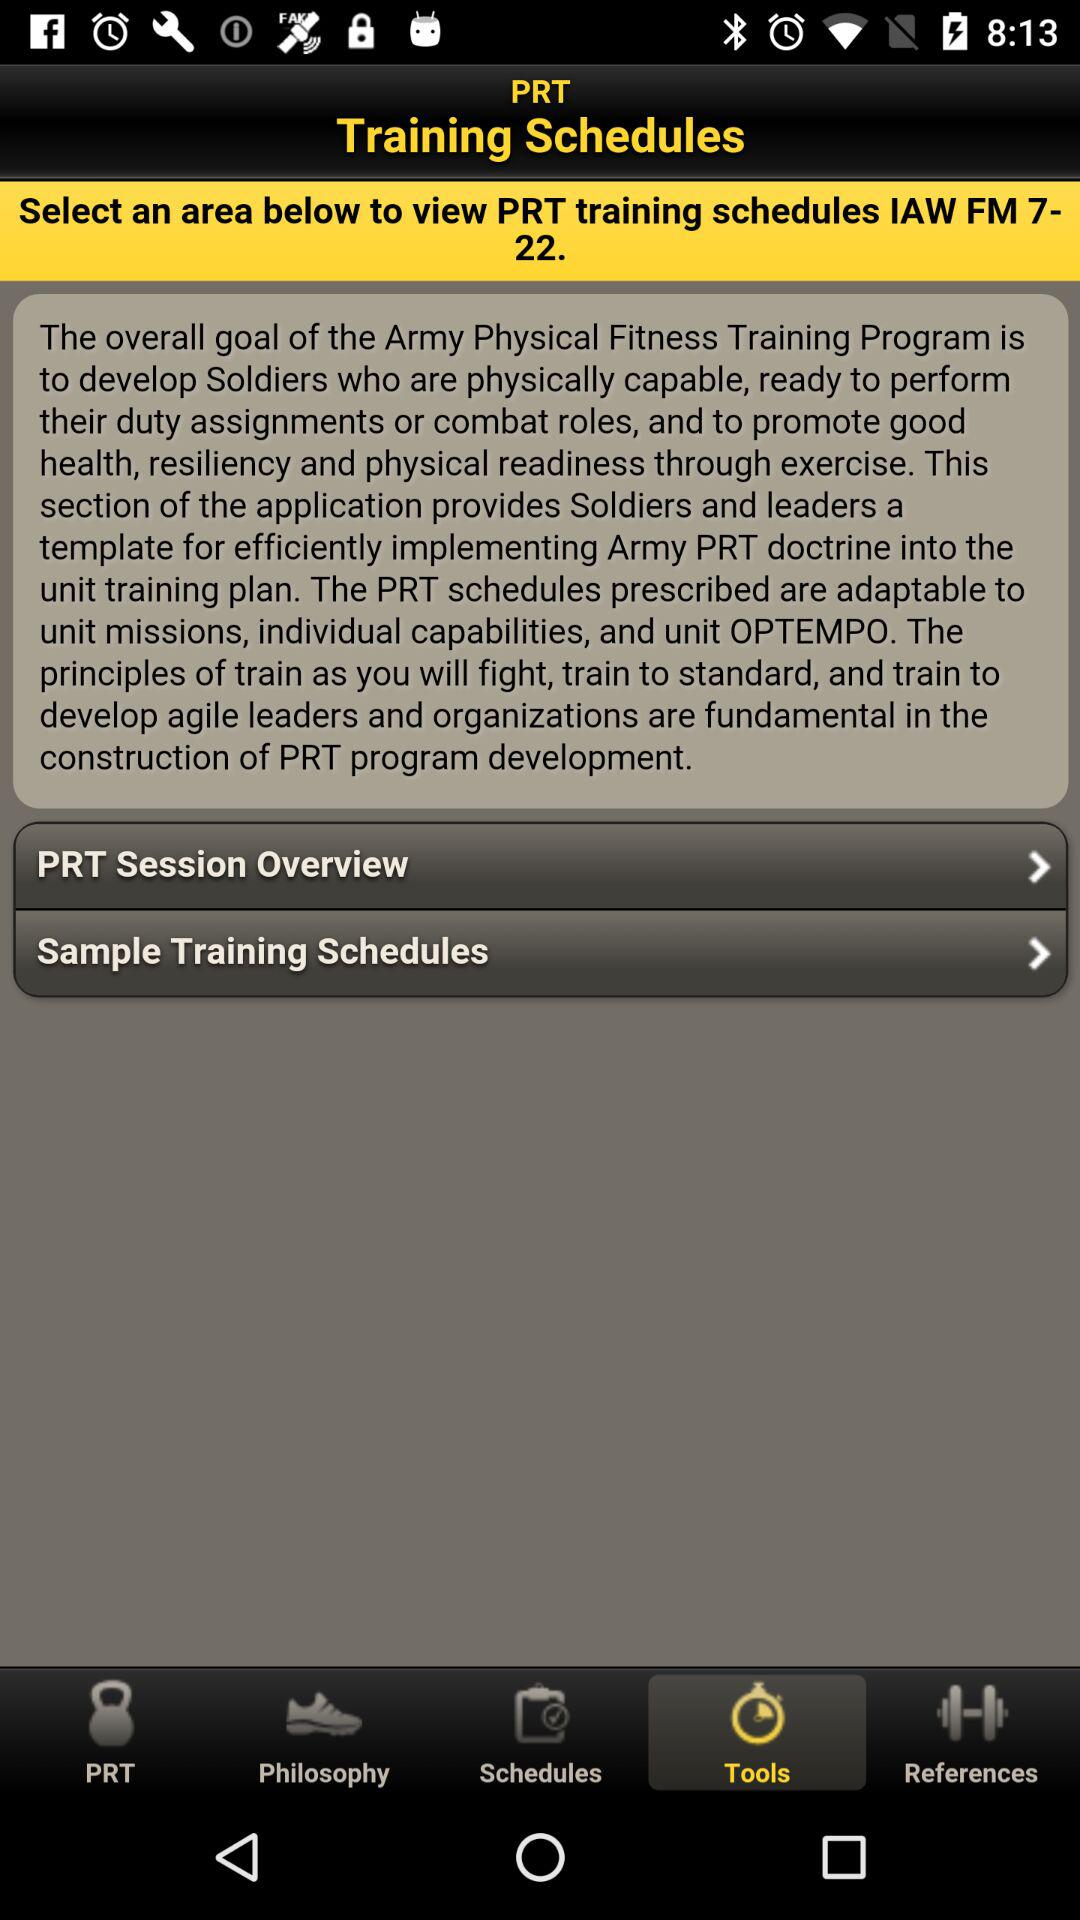Which tab is selected? The selected tab is "Tools". 